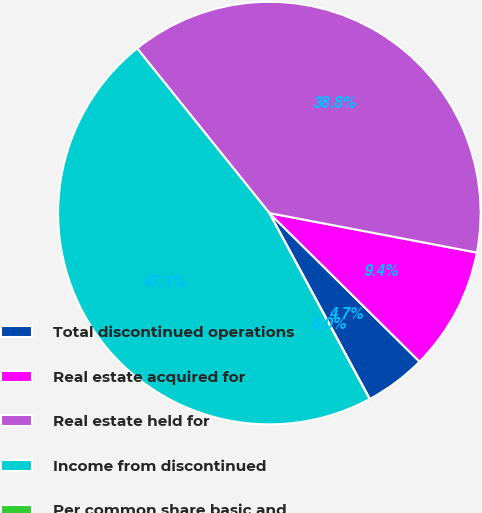Convert chart to OTSL. <chart><loc_0><loc_0><loc_500><loc_500><pie_chart><fcel>Total discontinued operations<fcel>Real estate acquired for<fcel>Real estate held for<fcel>Income from discontinued<fcel>Per common share basic and<nl><fcel>4.71%<fcel>9.42%<fcel>38.76%<fcel>47.11%<fcel>0.0%<nl></chart> 